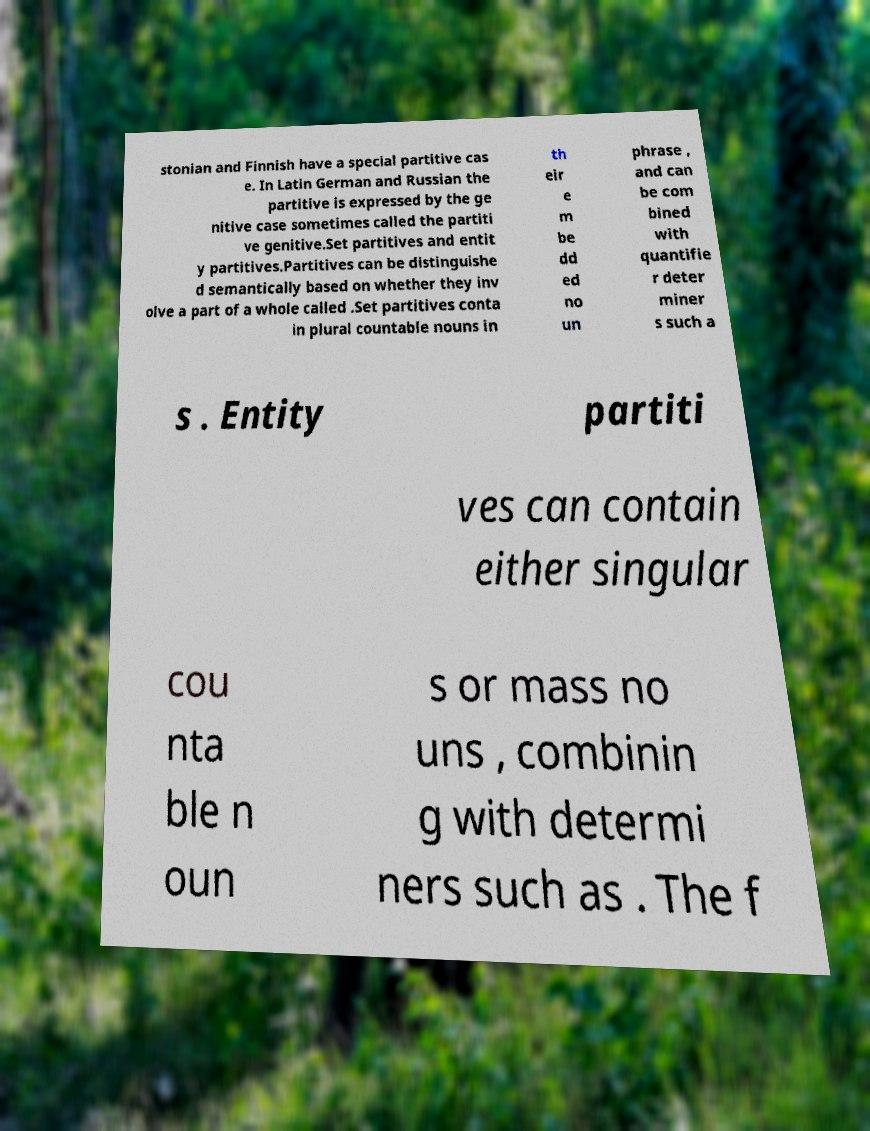Could you assist in decoding the text presented in this image and type it out clearly? stonian and Finnish have a special partitive cas e. In Latin German and Russian the partitive is expressed by the ge nitive case sometimes called the partiti ve genitive.Set partitives and entit y partitives.Partitives can be distinguishe d semantically based on whether they inv olve a part of a whole called .Set partitives conta in plural countable nouns in th eir e m be dd ed no un phrase , and can be com bined with quantifie r deter miner s such a s . Entity partiti ves can contain either singular cou nta ble n oun s or mass no uns , combinin g with determi ners such as . The f 